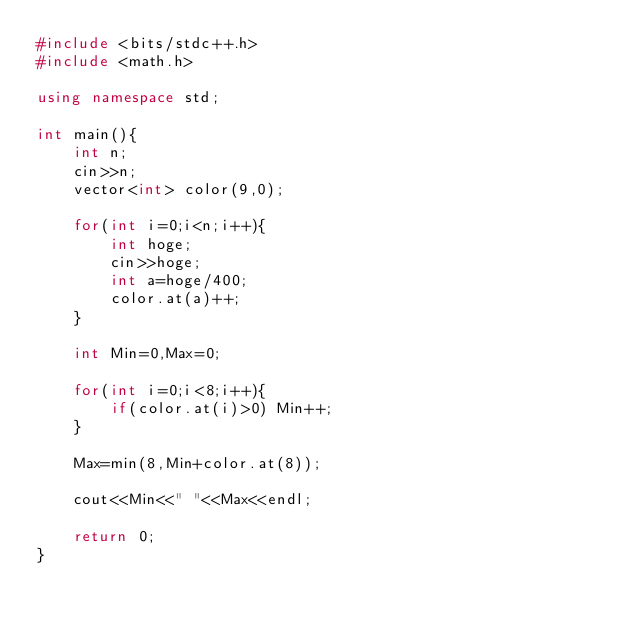Convert code to text. <code><loc_0><loc_0><loc_500><loc_500><_C++_>#include <bits/stdc++.h>
#include <math.h>

using namespace std;

int main(){
	int n;
	cin>>n;
	vector<int> color(9,0);

	for(int i=0;i<n;i++){
		int hoge;
		cin>>hoge;
		int a=hoge/400;
		color.at(a)++;
	}

	int Min=0,Max=0;

	for(int i=0;i<8;i++){
		if(color.at(i)>0) Min++;
	}

	Max=min(8,Min+color.at(8));

	cout<<Min<<" "<<Max<<endl;

	return 0;
}
</code> 